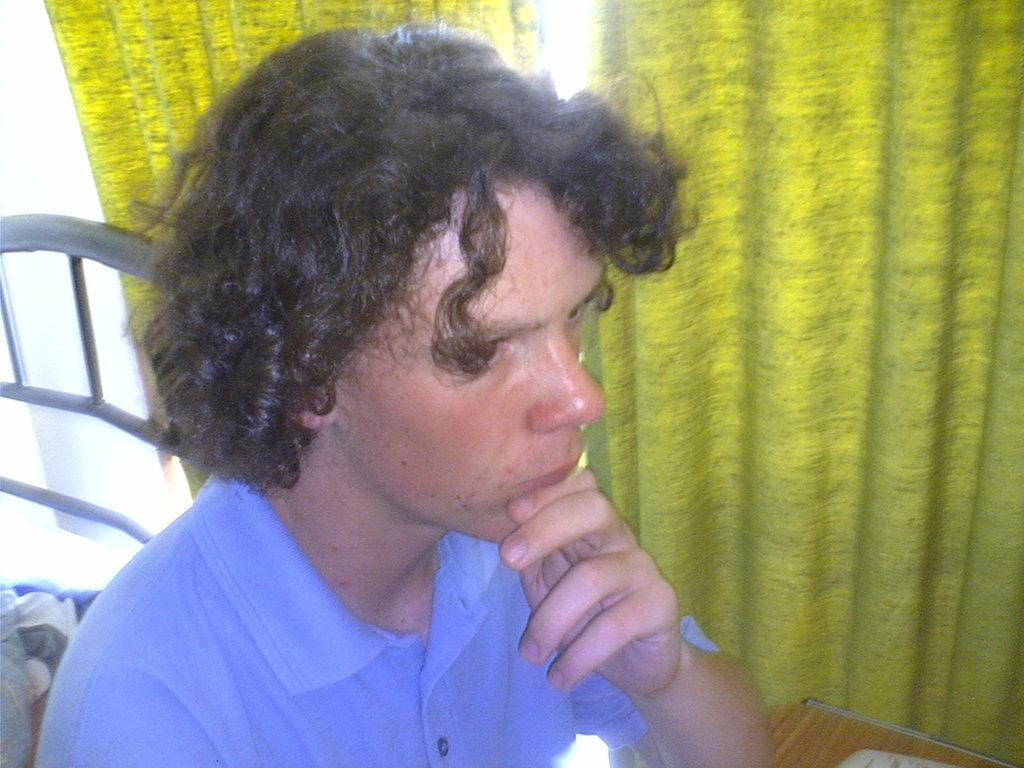Who or what is present in the image? There is a person in the image. What object can be seen in the image besides the person? There is a table in the image. Where is the table located in the image? The table is located at the right bottom of the image. What can be seen in the background of the image? There are curtains in the background of the image. What type of apparatus is being used by the person in the image? There is no apparatus visible in the image; the person is not using any equipment or tools. What kind of plants can be seen in the image? There are no plants present in the image; the focus is on the person and the table. 